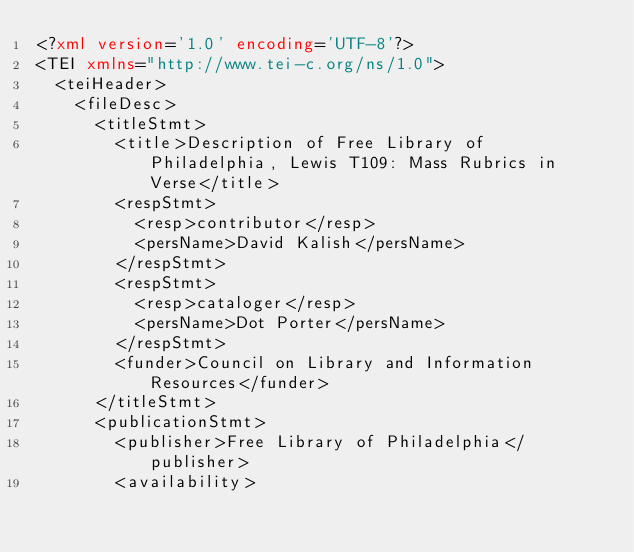<code> <loc_0><loc_0><loc_500><loc_500><_XML_><?xml version='1.0' encoding='UTF-8'?>
<TEI xmlns="http://www.tei-c.org/ns/1.0">
  <teiHeader>
    <fileDesc>
      <titleStmt>
        <title>Description of Free Library of Philadelphia, Lewis T109: Mass Rubrics in Verse</title>
        <respStmt>
          <resp>contributor</resp>
          <persName>David Kalish</persName>
        </respStmt>
        <respStmt>
          <resp>cataloger</resp>
          <persName>Dot Porter</persName>
        </respStmt>
        <funder>Council on Library and Information Resources</funder>
      </titleStmt>
      <publicationStmt>
        <publisher>Free Library of Philadelphia</publisher>
        <availability></code> 